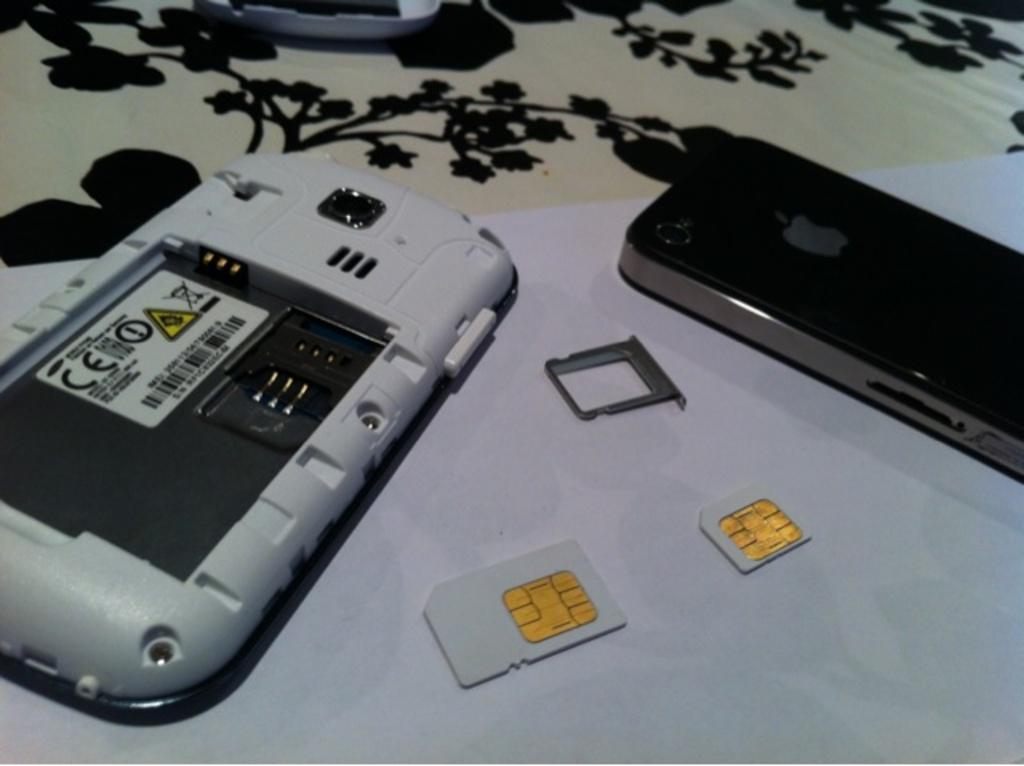In one or two sentences, can you explain what this image depicts? In this image I can see mobiles, sim cards and houseplants. This image is taken may be during night. 